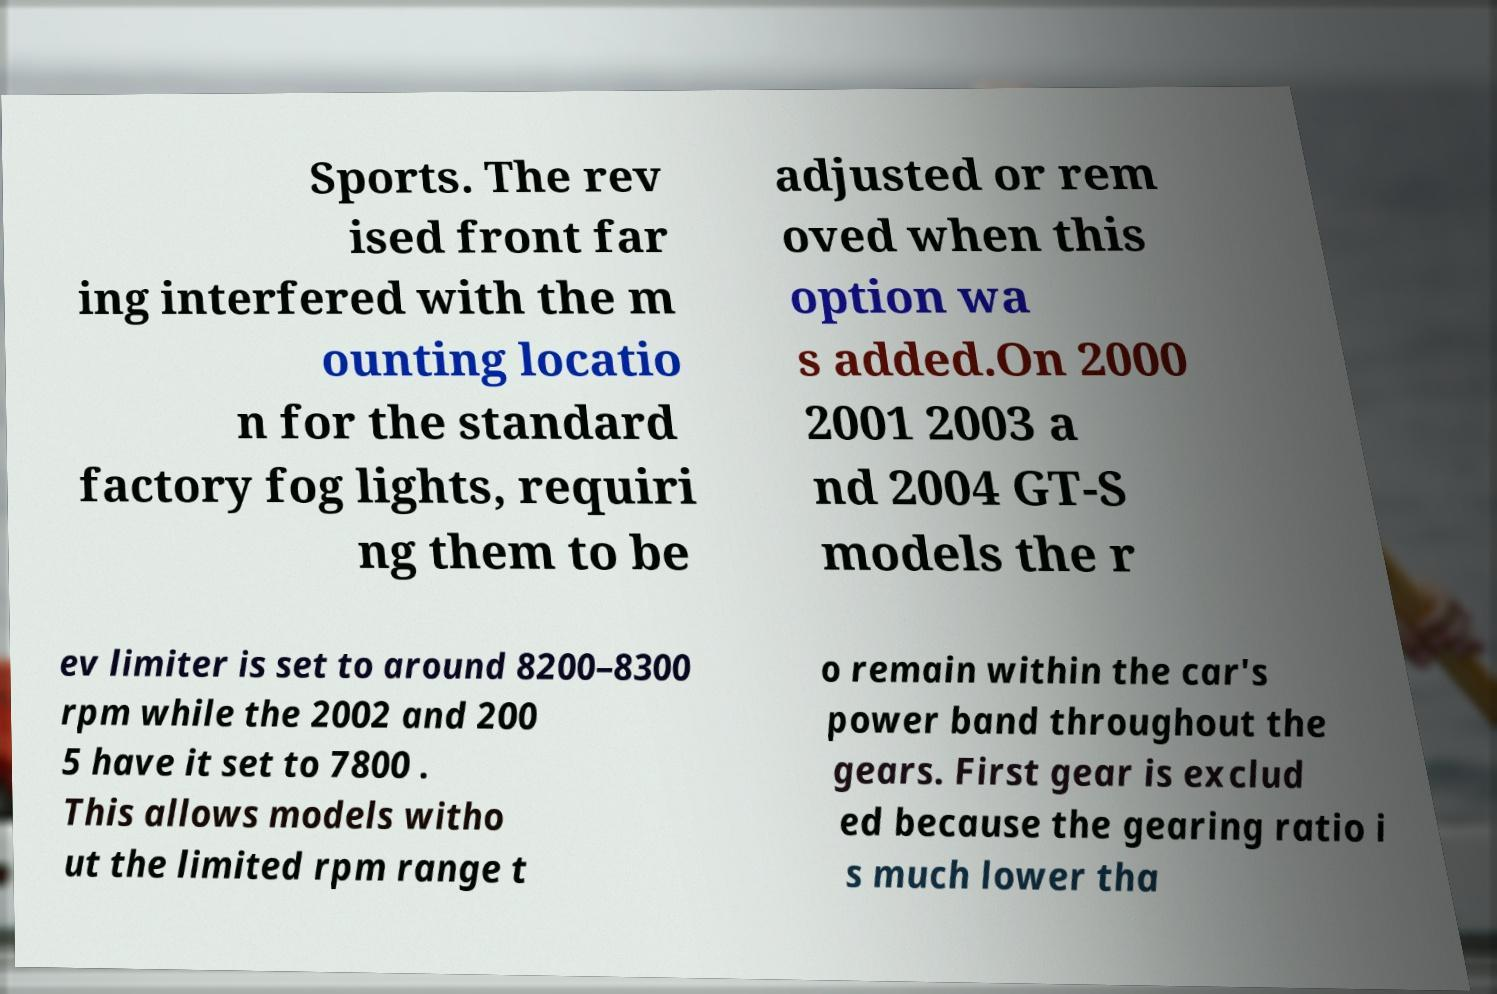Could you extract and type out the text from this image? Sports. The rev ised front far ing interfered with the m ounting locatio n for the standard factory fog lights, requiri ng them to be adjusted or rem oved when this option wa s added.On 2000 2001 2003 a nd 2004 GT-S models the r ev limiter is set to around 8200–8300 rpm while the 2002 and 200 5 have it set to 7800 . This allows models witho ut the limited rpm range t o remain within the car's power band throughout the gears. First gear is exclud ed because the gearing ratio i s much lower tha 